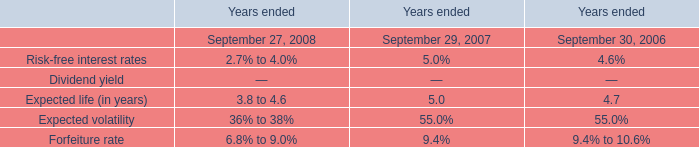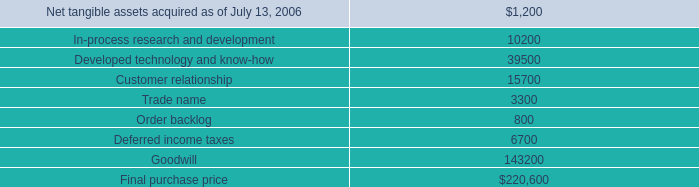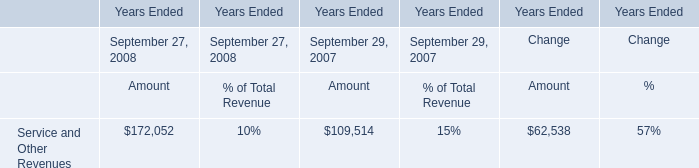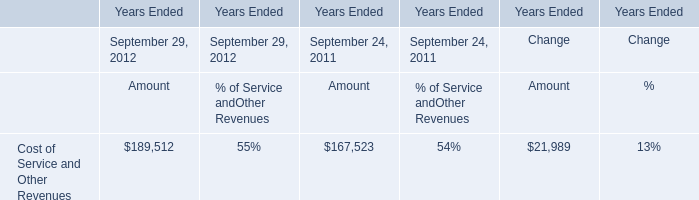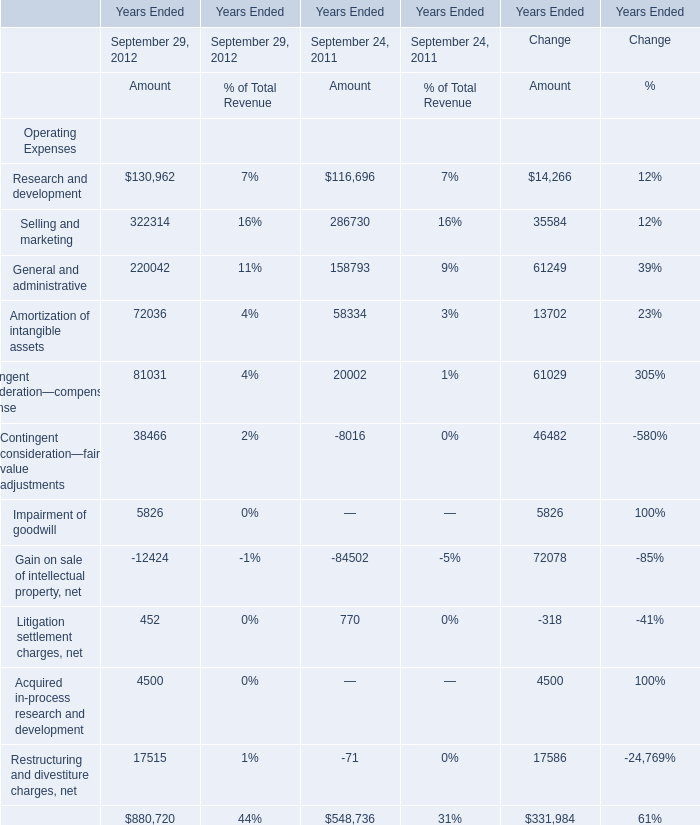What is the average amount of Impairment of goodwill of Years Ended Change Amount, and Net tangible assets acquired as of July 13, 2006 ? 
Computations: ((5826.0 + 1200.0) / 2)
Answer: 3513.0. 